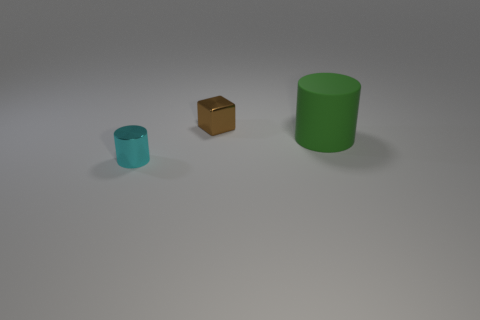Is there any other thing that has the same material as the green cylinder?
Ensure brevity in your answer.  No. Is there any other thing that has the same shape as the small brown thing?
Offer a terse response. No. What color is the matte cylinder?
Offer a terse response. Green. What is the shape of the object in front of the big cylinder?
Provide a succinct answer. Cylinder. What number of red objects are large cylinders or small metallic objects?
Ensure brevity in your answer.  0. There is a cube that is the same material as the tiny cyan cylinder; what color is it?
Offer a terse response. Brown. Does the shiny cylinder have the same color as the rubber object in front of the small cube?
Your answer should be very brief. No. There is a thing that is behind the tiny shiny cylinder and to the left of the big green rubber cylinder; what is its color?
Your response must be concise. Brown. There is a small brown metallic object; how many cylinders are in front of it?
Ensure brevity in your answer.  2. What number of things are either brown cubes or small shiny objects that are to the right of the cyan cylinder?
Make the answer very short. 1. 